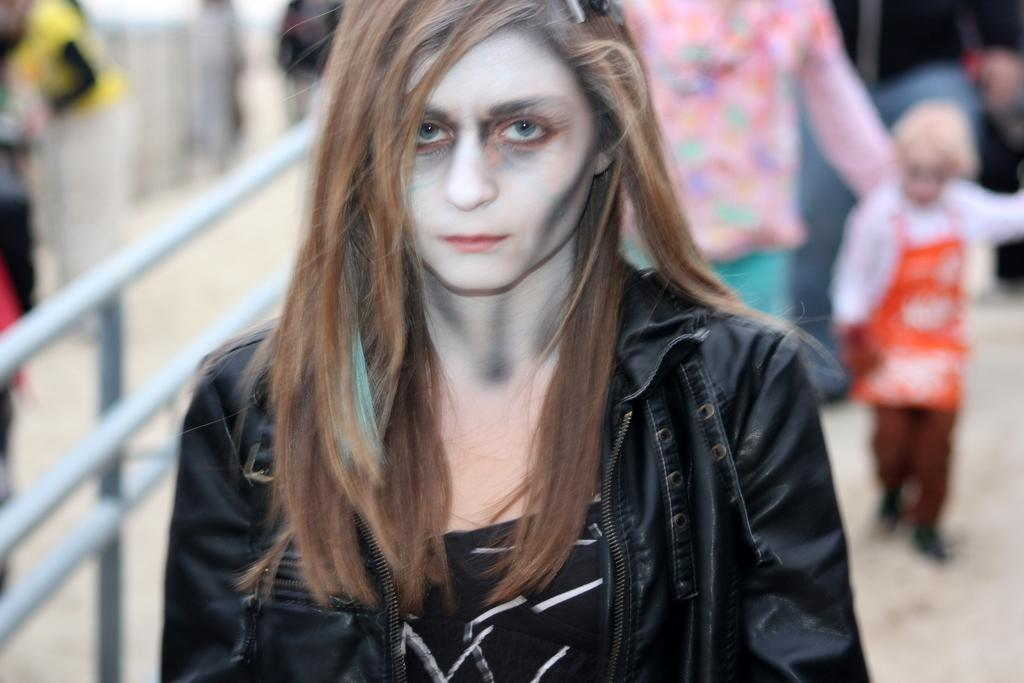Who is the main subject in the image? There is a woman in the image. What is the woman wearing? The woman is wearing a black jacket. Are there any other people in the image? Yes, there are two people walking behind the woman. What can be seen beside the woman? There is a part of the railing visible beside the woman. What is the smell of the society in the image? There is no mention of a society or any smells in the image; it features a woman wearing a black jacket with two people walking behind her and a part of the railing visible beside her. 